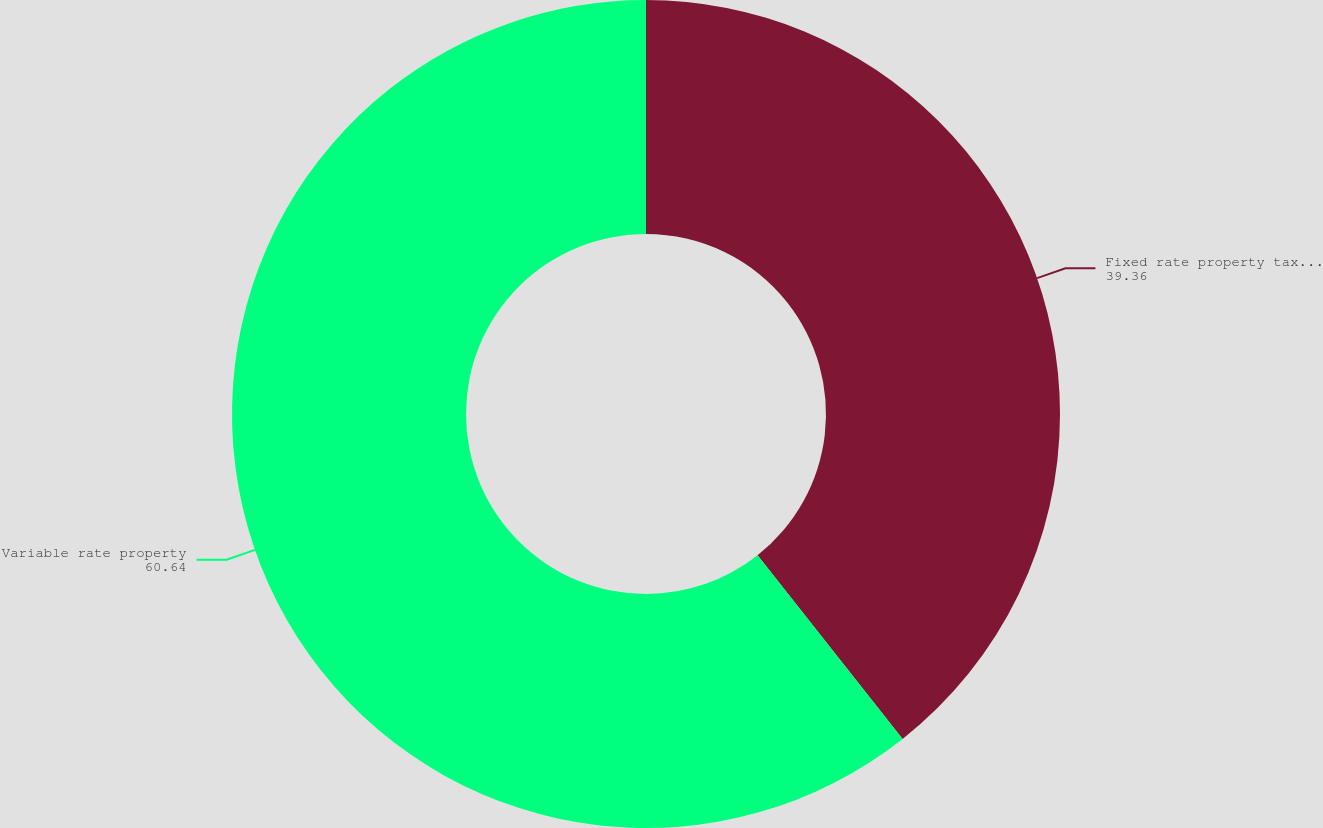Convert chart. <chart><loc_0><loc_0><loc_500><loc_500><pie_chart><fcel>Fixed rate property tax-exempt<fcel>Variable rate property<nl><fcel>39.36%<fcel>60.64%<nl></chart> 